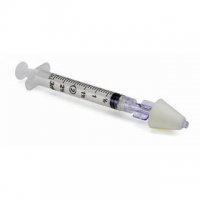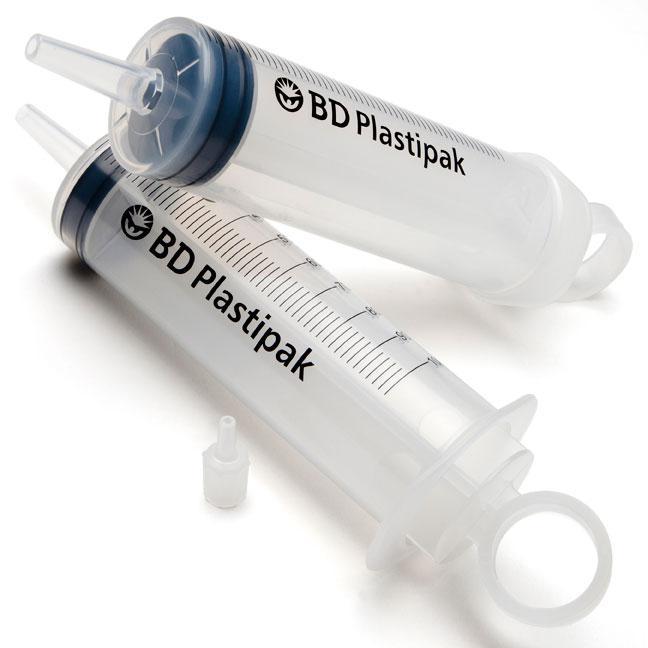The first image is the image on the left, the second image is the image on the right. Evaluate the accuracy of this statement regarding the images: "In one image, the sharp end of a needle is enclosed in a cone-shaped plastic tip.". Is it true? Answer yes or no. Yes. 